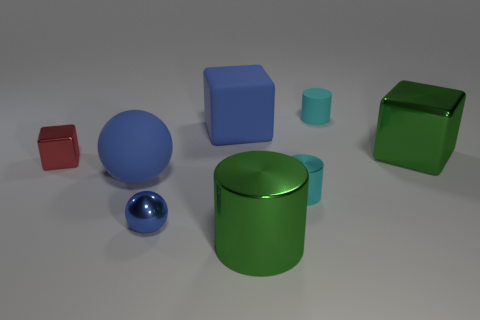Are the green cube and the tiny red object made of the same material?
Your answer should be compact. Yes. What is the shape of the tiny cyan thing that is made of the same material as the small red thing?
Offer a very short reply. Cylinder. Is there anything else that is the same color as the tiny cube?
Keep it short and to the point. No. The shiny block that is right of the tiny metal cylinder is what color?
Provide a short and direct response. Green. Is the color of the tiny cylinder that is on the left side of the cyan matte thing the same as the small matte object?
Ensure brevity in your answer.  Yes. What material is the big thing that is the same shape as the tiny blue metallic object?
Your answer should be compact. Rubber. How many green shiny objects are the same size as the red thing?
Provide a succinct answer. 0. What shape is the cyan shiny thing?
Offer a very short reply. Cylinder. What size is the object that is both to the right of the large cylinder and in front of the large green block?
Your response must be concise. Small. There is a block that is on the right side of the green cylinder; what material is it?
Your answer should be very brief. Metal. 